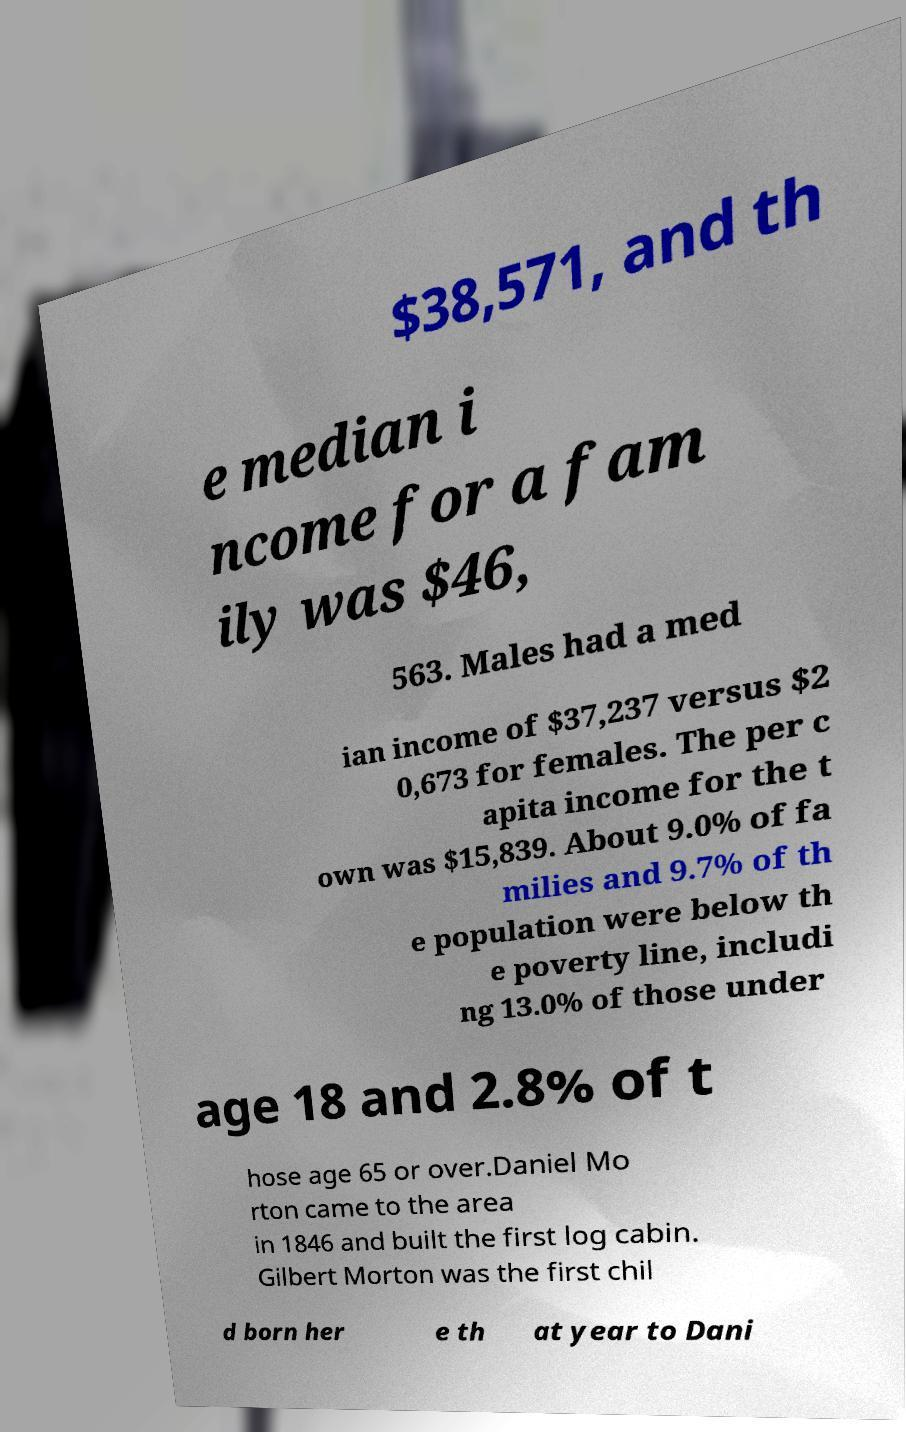Could you extract and type out the text from this image? $38,571, and th e median i ncome for a fam ily was $46, 563. Males had a med ian income of $37,237 versus $2 0,673 for females. The per c apita income for the t own was $15,839. About 9.0% of fa milies and 9.7% of th e population were below th e poverty line, includi ng 13.0% of those under age 18 and 2.8% of t hose age 65 or over.Daniel Mo rton came to the area in 1846 and built the first log cabin. Gilbert Morton was the first chil d born her e th at year to Dani 